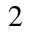<formula> <loc_0><loc_0><loc_500><loc_500>^ { 2 }</formula> 